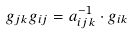Convert formula to latex. <formula><loc_0><loc_0><loc_500><loc_500>g _ { j k } g _ { i j } = a _ { i j k } ^ { - 1 } \cdot g _ { i k }</formula> 